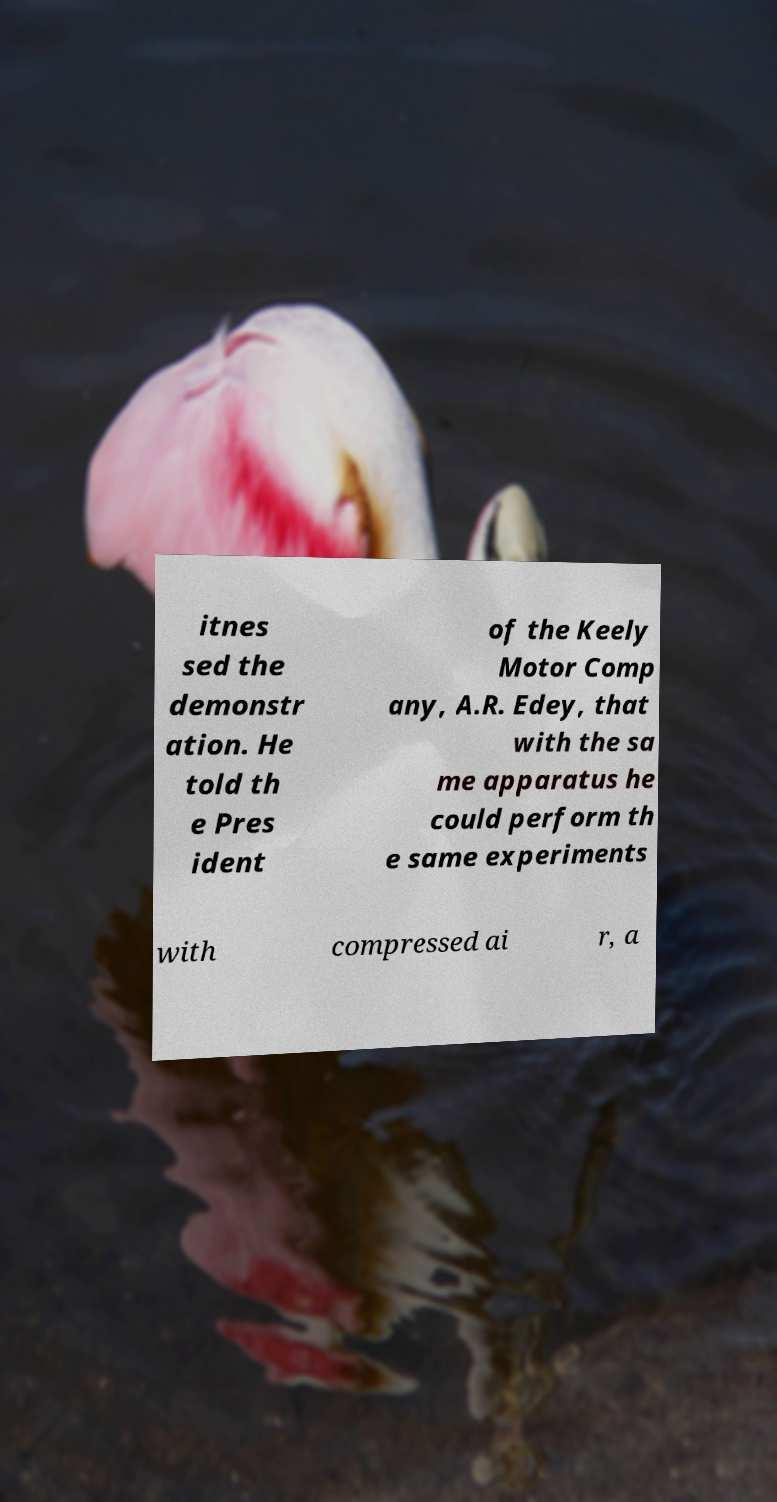Please identify and transcribe the text found in this image. itnes sed the demonstr ation. He told th e Pres ident of the Keely Motor Comp any, A.R. Edey, that with the sa me apparatus he could perform th e same experiments with compressed ai r, a 